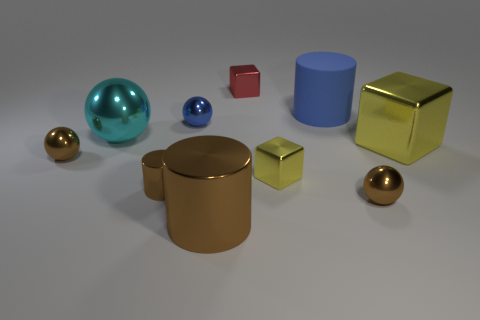Subtract all balls. How many objects are left? 6 Subtract all yellow metal things. Subtract all small blue objects. How many objects are left? 7 Add 8 blue objects. How many blue objects are left? 10 Add 8 small yellow objects. How many small yellow objects exist? 9 Subtract 0 gray balls. How many objects are left? 10 